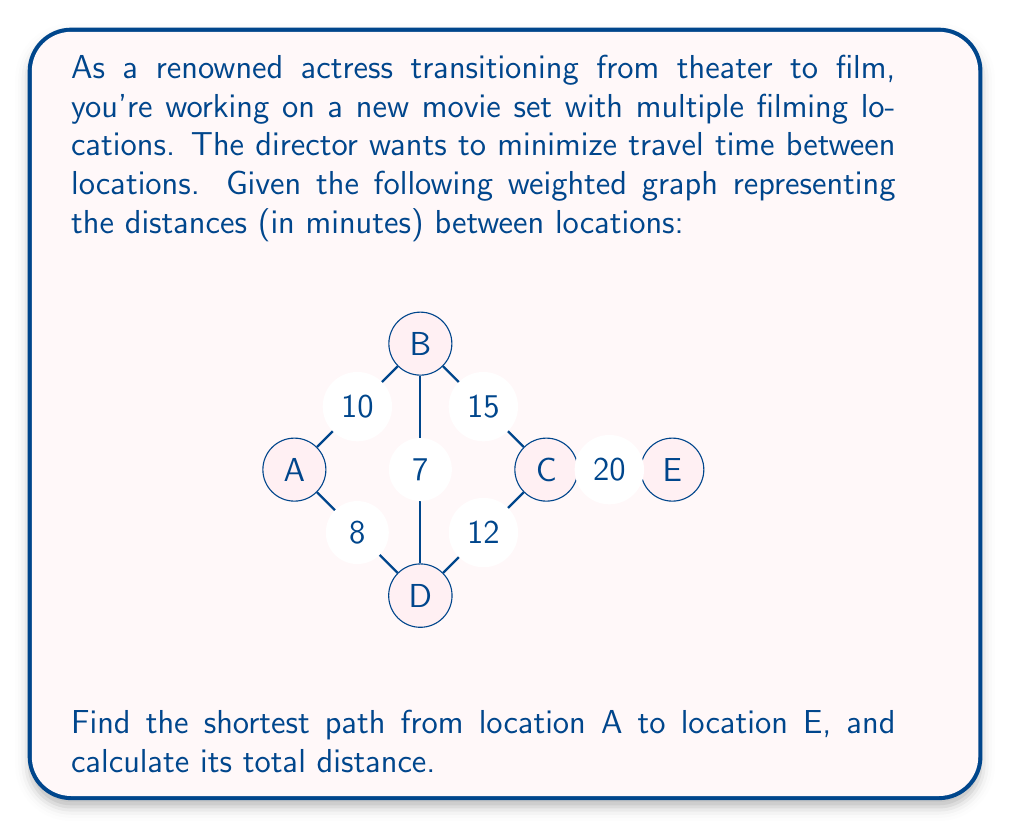Could you help me with this problem? To solve this problem, we'll use Dijkstra's algorithm to find the shortest path from A to E.

Step 1: Initialize distances
$$d(A) = 0, d(B) = \infty, d(C) = \infty, d(D) = \infty, d(E) = \infty$$

Step 2: Start from A and update neighbors
$$d(B) = 10, d(D) = 8$$

Step 3: Move to D (shortest unvisited)
Update: $$d(B) = \min(d(B), d(D) + 7) = \min(10, 15) = 10$$
$$d(C) = d(D) + 12 = 20$$

Step 4: Move to B
Update: $$d(C) = \min(d(C), d(B) + 15) = \min(20, 25) = 20$$

Step 5: Move to C
Update: $$d(E) = d(C) + 20 = 40$$

The algorithm terminates as we've reached E.

The shortest path is A → D → C → E with a total distance of 40 minutes.
Answer: The shortest path from A to E is A → D → C → E, with a total distance of 40 minutes. 